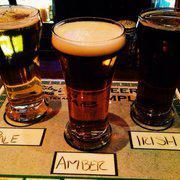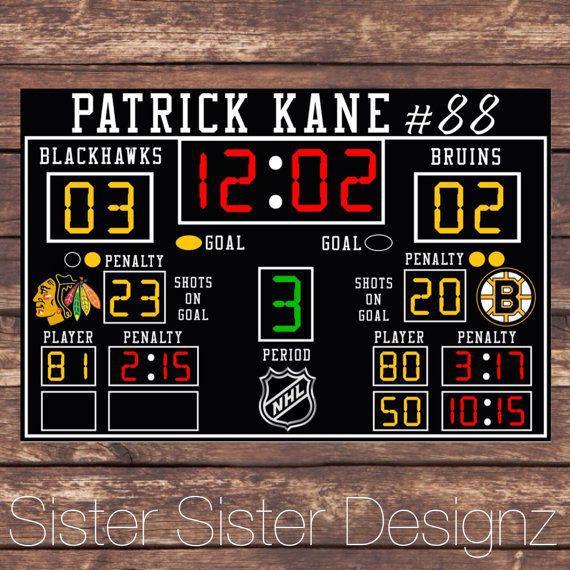The first image is the image on the left, the second image is the image on the right. Considering the images on both sides, is "One image shows two camera-facing smiling women posed side-by-side behind a table-like surface." valid? Answer yes or no. No. The first image is the image on the left, the second image is the image on the right. For the images displayed, is the sentence "One scoreboard is lit up with neon red and yellow colors." factually correct? Answer yes or no. Yes. 